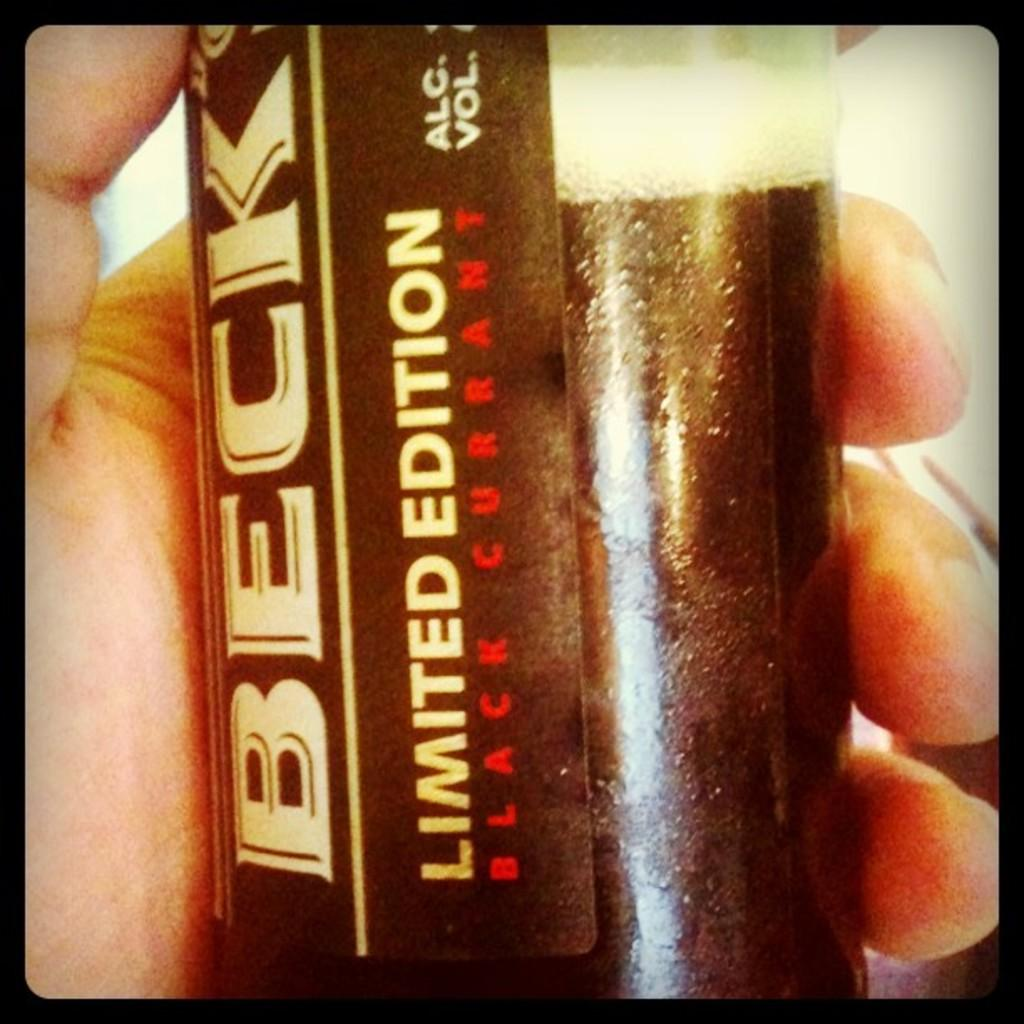What can be seen in the image related to a person's hand? There is a person's hand in the image. What is the person's hand holding? The person's hand is holding a coke bottle. Can you describe any additional details about the coke bottle? There is a company sticker on the coke bottle. What type of button can be seen on the person's hand in the image? There is no button present on the person's hand in the image. 